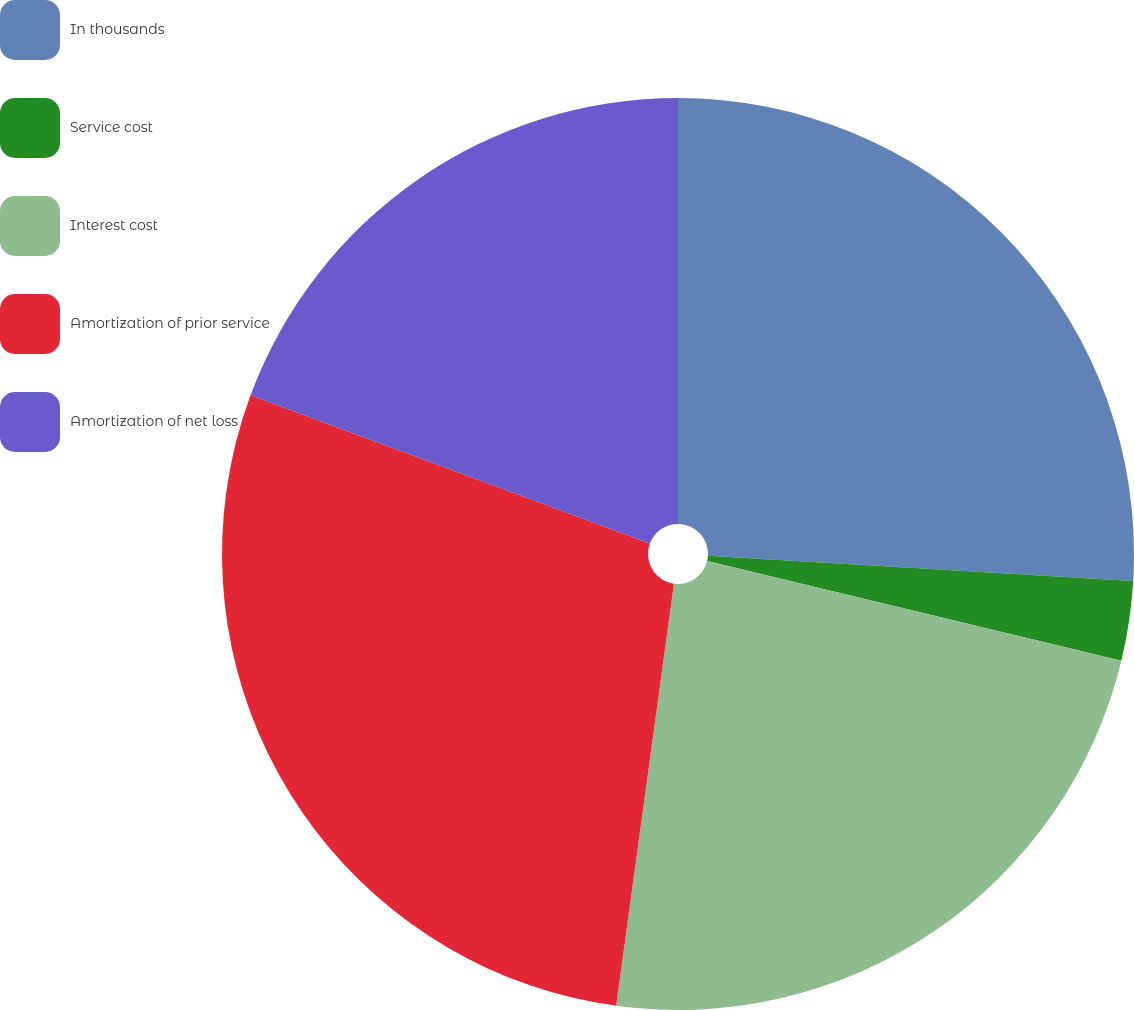<chart> <loc_0><loc_0><loc_500><loc_500><pie_chart><fcel>In thousands<fcel>Service cost<fcel>Interest cost<fcel>Amortization of prior service<fcel>Amortization of net loss<nl><fcel>25.94%<fcel>2.82%<fcel>23.4%<fcel>28.49%<fcel>19.34%<nl></chart> 